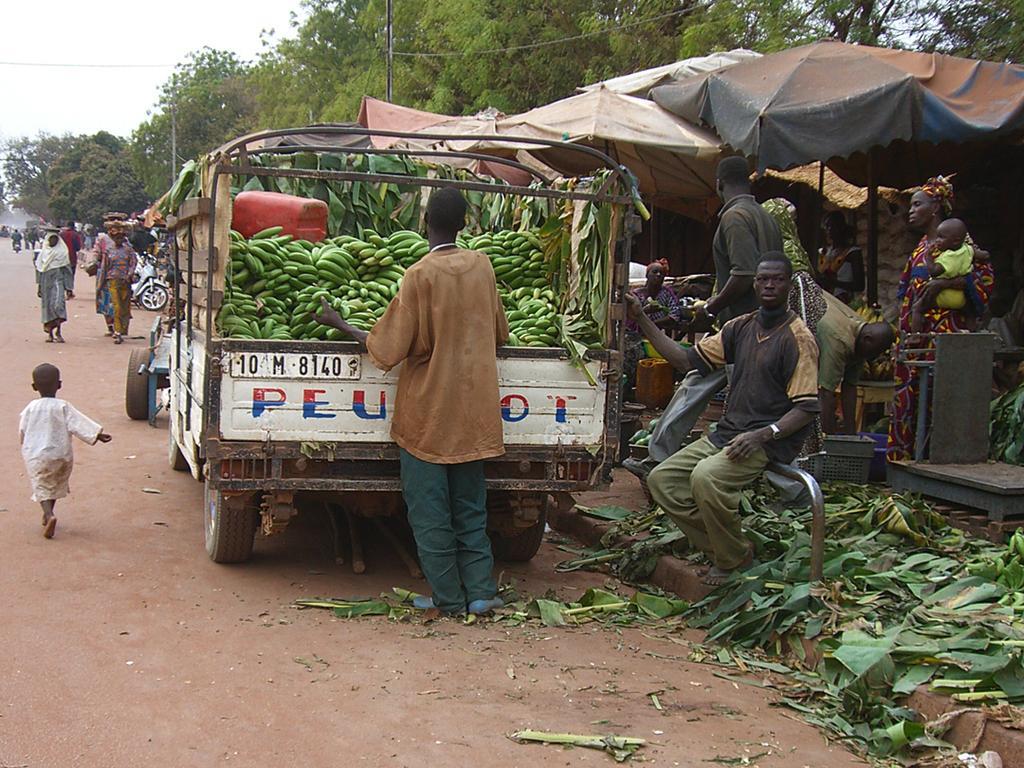How would you summarize this image in a sentence or two? In the image there is a truck and plenty of bananas were kept on that truck, there are few people on the right side of the truck and many people were moving on the road, on the right side there are plenty of trees behind the truck. 